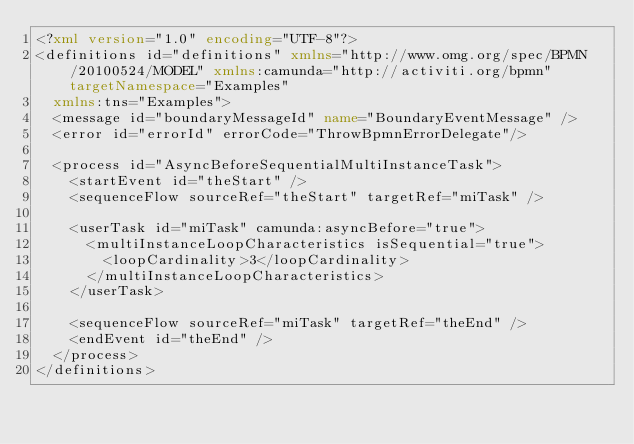<code> <loc_0><loc_0><loc_500><loc_500><_XML_><?xml version="1.0" encoding="UTF-8"?>
<definitions id="definitions" xmlns="http://www.omg.org/spec/BPMN/20100524/MODEL" xmlns:camunda="http://activiti.org/bpmn" targetNamespace="Examples"
  xmlns:tns="Examples">
  <message id="boundaryMessageId" name="BoundaryEventMessage" />
  <error id="errorId" errorCode="ThrowBpmnErrorDelegate"/>
  
  <process id="AsyncBeforeSequentialMultiInstanceTask">
    <startEvent id="theStart" />
    <sequenceFlow sourceRef="theStart" targetRef="miTask" />
    
    <userTask id="miTask" camunda:asyncBefore="true">
      <multiInstanceLoopCharacteristics isSequential="true">
        <loopCardinality>3</loopCardinality>
      </multiInstanceLoopCharacteristics>
    </userTask>
    
    <sequenceFlow sourceRef="miTask" targetRef="theEnd" />
    <endEvent id="theEnd" />
  </process>
</definitions></code> 